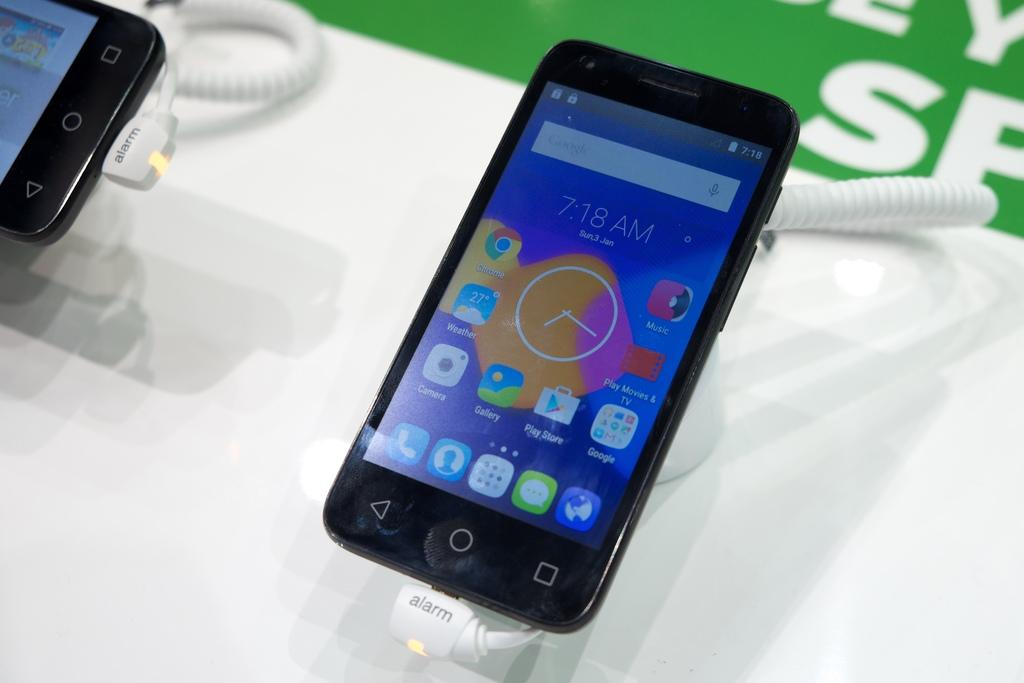What electronic devices are visible in the image? There are mobile phones in the image. How are the mobile phones connected in the image? The mobile phones are connected with cable wires. Where are the mobile phones and cable wires located in the image? The mobile phones and cable wires are present over a place. What type of stamp can be seen on the farmer's hand in the image? There is no farmer or stamp present in the image; it features mobile phones connected with cable wires. 